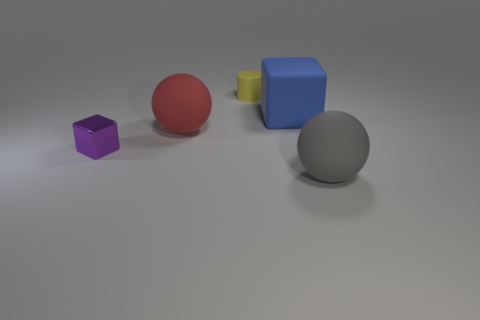What shape is the tiny metallic object?
Make the answer very short. Cube. Are there any big matte objects in front of the tiny shiny object?
Provide a succinct answer. Yes. Is the big red object made of the same material as the small thing behind the big red matte ball?
Keep it short and to the point. Yes. There is a large rubber thing that is left of the matte cylinder; is its shape the same as the gray object?
Keep it short and to the point. Yes. What number of tiny purple objects have the same material as the blue block?
Give a very brief answer. 0. What number of objects are objects that are in front of the large blue object or tiny purple cylinders?
Offer a very short reply. 3. The gray rubber object has what size?
Offer a very short reply. Large. What is the large sphere to the left of the big matte sphere on the right side of the large red object made of?
Keep it short and to the point. Rubber. There is a ball left of the yellow cylinder; does it have the same size as the blue object?
Offer a terse response. Yes. Are there any rubber objects of the same color as the rubber cylinder?
Offer a very short reply. No. 